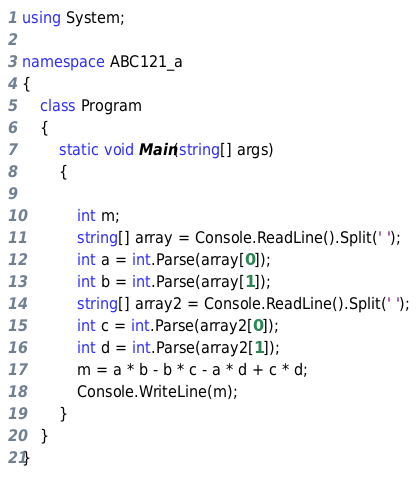Convert code to text. <code><loc_0><loc_0><loc_500><loc_500><_C#_>using System;

namespace ABC121_a
{
    class Program
    {
        static void Main(string[] args)
        {
            
            int m; 
            string[] array = Console.ReadLine().Split(' ');
            int a = int.Parse(array[0]);
            int b = int.Parse(array[1]);
            string[] array2 = Console.ReadLine().Split(' ');
            int c = int.Parse(array2[0]);
            int d = int.Parse(array2[1]);
            m = a * b - b * c - a * d + c * d;
            Console.WriteLine(m);
        }
    }
}
</code> 